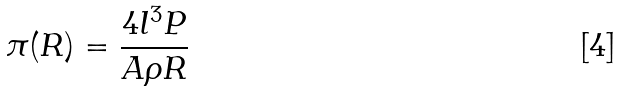<formula> <loc_0><loc_0><loc_500><loc_500>\pi ( R ) = \frac { 4 l ^ { 3 } P } { A \rho R }</formula> 